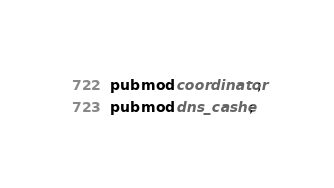Convert code to text. <code><loc_0><loc_0><loc_500><loc_500><_Rust_>pub mod coordinator;
pub mod dns_cashe;

</code> 